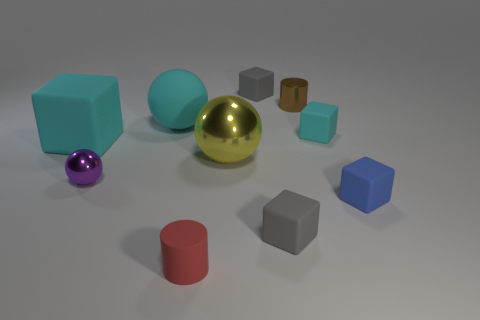Subtract all tiny blue cubes. How many cubes are left? 4 Subtract 2 blocks. How many blocks are left? 3 Subtract all blue blocks. How many blocks are left? 4 Subtract all red blocks. Subtract all yellow cylinders. How many blocks are left? 5 Subtract all balls. How many objects are left? 7 Add 2 yellow shiny blocks. How many yellow shiny blocks exist? 2 Subtract 1 yellow balls. How many objects are left? 9 Subtract all tiny blue things. Subtract all gray things. How many objects are left? 7 Add 3 small metallic balls. How many small metallic balls are left? 4 